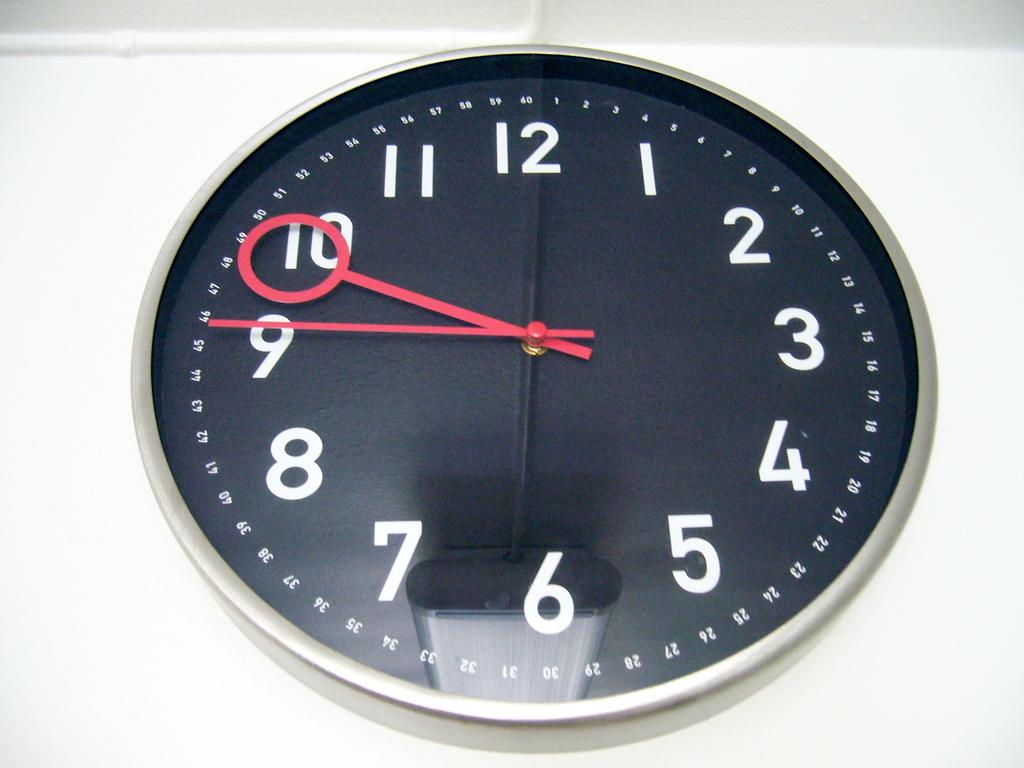Provide a one-sentence caption for the provided image. The time on the black and silver clock is 9:46 P.M. 